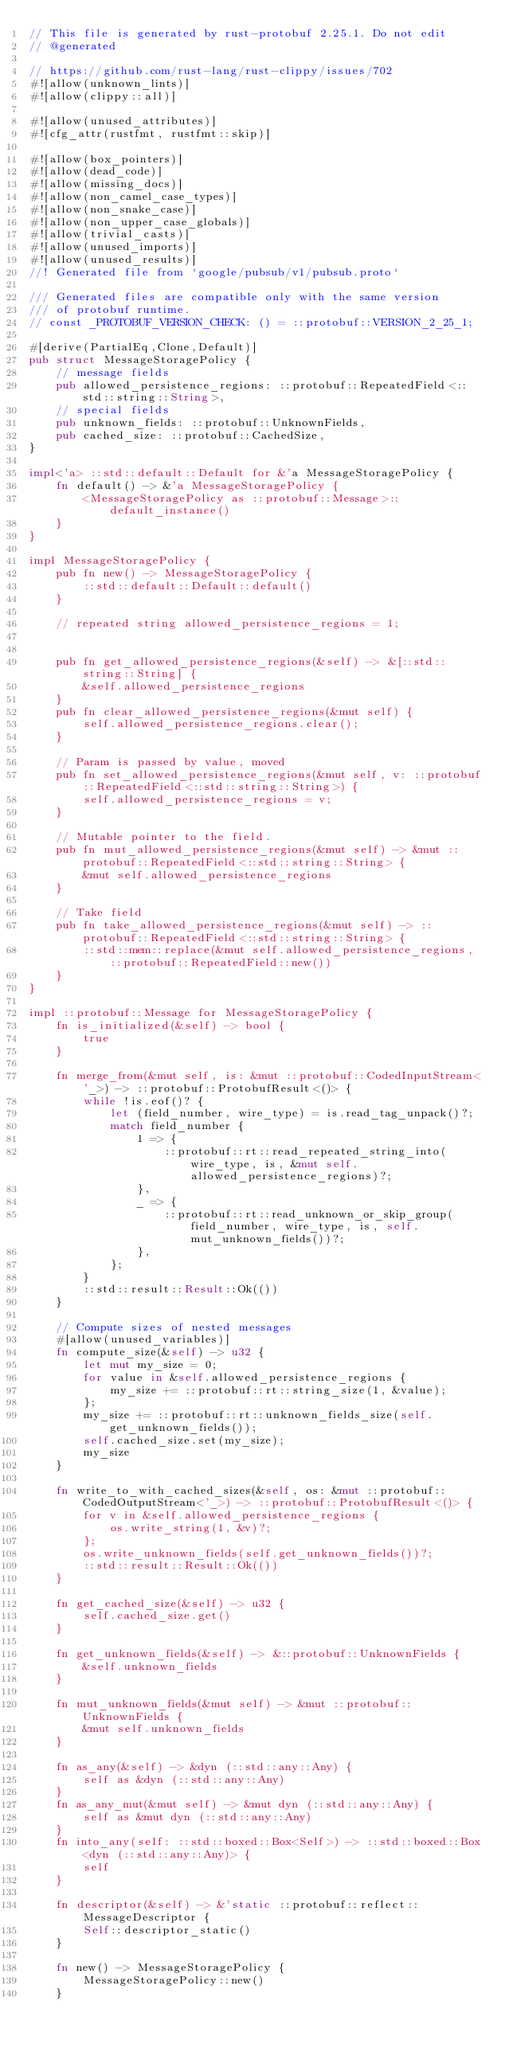Convert code to text. <code><loc_0><loc_0><loc_500><loc_500><_Rust_>// This file is generated by rust-protobuf 2.25.1. Do not edit
// @generated

// https://github.com/rust-lang/rust-clippy/issues/702
#![allow(unknown_lints)]
#![allow(clippy::all)]

#![allow(unused_attributes)]
#![cfg_attr(rustfmt, rustfmt::skip)]

#![allow(box_pointers)]
#![allow(dead_code)]
#![allow(missing_docs)]
#![allow(non_camel_case_types)]
#![allow(non_snake_case)]
#![allow(non_upper_case_globals)]
#![allow(trivial_casts)]
#![allow(unused_imports)]
#![allow(unused_results)]
//! Generated file from `google/pubsub/v1/pubsub.proto`

/// Generated files are compatible only with the same version
/// of protobuf runtime.
// const _PROTOBUF_VERSION_CHECK: () = ::protobuf::VERSION_2_25_1;

#[derive(PartialEq,Clone,Default)]
pub struct MessageStoragePolicy {
    // message fields
    pub allowed_persistence_regions: ::protobuf::RepeatedField<::std::string::String>,
    // special fields
    pub unknown_fields: ::protobuf::UnknownFields,
    pub cached_size: ::protobuf::CachedSize,
}

impl<'a> ::std::default::Default for &'a MessageStoragePolicy {
    fn default() -> &'a MessageStoragePolicy {
        <MessageStoragePolicy as ::protobuf::Message>::default_instance()
    }
}

impl MessageStoragePolicy {
    pub fn new() -> MessageStoragePolicy {
        ::std::default::Default::default()
    }

    // repeated string allowed_persistence_regions = 1;


    pub fn get_allowed_persistence_regions(&self) -> &[::std::string::String] {
        &self.allowed_persistence_regions
    }
    pub fn clear_allowed_persistence_regions(&mut self) {
        self.allowed_persistence_regions.clear();
    }

    // Param is passed by value, moved
    pub fn set_allowed_persistence_regions(&mut self, v: ::protobuf::RepeatedField<::std::string::String>) {
        self.allowed_persistence_regions = v;
    }

    // Mutable pointer to the field.
    pub fn mut_allowed_persistence_regions(&mut self) -> &mut ::protobuf::RepeatedField<::std::string::String> {
        &mut self.allowed_persistence_regions
    }

    // Take field
    pub fn take_allowed_persistence_regions(&mut self) -> ::protobuf::RepeatedField<::std::string::String> {
        ::std::mem::replace(&mut self.allowed_persistence_regions, ::protobuf::RepeatedField::new())
    }
}

impl ::protobuf::Message for MessageStoragePolicy {
    fn is_initialized(&self) -> bool {
        true
    }

    fn merge_from(&mut self, is: &mut ::protobuf::CodedInputStream<'_>) -> ::protobuf::ProtobufResult<()> {
        while !is.eof()? {
            let (field_number, wire_type) = is.read_tag_unpack()?;
            match field_number {
                1 => {
                    ::protobuf::rt::read_repeated_string_into(wire_type, is, &mut self.allowed_persistence_regions)?;
                },
                _ => {
                    ::protobuf::rt::read_unknown_or_skip_group(field_number, wire_type, is, self.mut_unknown_fields())?;
                },
            };
        }
        ::std::result::Result::Ok(())
    }

    // Compute sizes of nested messages
    #[allow(unused_variables)]
    fn compute_size(&self) -> u32 {
        let mut my_size = 0;
        for value in &self.allowed_persistence_regions {
            my_size += ::protobuf::rt::string_size(1, &value);
        };
        my_size += ::protobuf::rt::unknown_fields_size(self.get_unknown_fields());
        self.cached_size.set(my_size);
        my_size
    }

    fn write_to_with_cached_sizes(&self, os: &mut ::protobuf::CodedOutputStream<'_>) -> ::protobuf::ProtobufResult<()> {
        for v in &self.allowed_persistence_regions {
            os.write_string(1, &v)?;
        };
        os.write_unknown_fields(self.get_unknown_fields())?;
        ::std::result::Result::Ok(())
    }

    fn get_cached_size(&self) -> u32 {
        self.cached_size.get()
    }

    fn get_unknown_fields(&self) -> &::protobuf::UnknownFields {
        &self.unknown_fields
    }

    fn mut_unknown_fields(&mut self) -> &mut ::protobuf::UnknownFields {
        &mut self.unknown_fields
    }

    fn as_any(&self) -> &dyn (::std::any::Any) {
        self as &dyn (::std::any::Any)
    }
    fn as_any_mut(&mut self) -> &mut dyn (::std::any::Any) {
        self as &mut dyn (::std::any::Any)
    }
    fn into_any(self: ::std::boxed::Box<Self>) -> ::std::boxed::Box<dyn (::std::any::Any)> {
        self
    }

    fn descriptor(&self) -> &'static ::protobuf::reflect::MessageDescriptor {
        Self::descriptor_static()
    }

    fn new() -> MessageStoragePolicy {
        MessageStoragePolicy::new()
    }
</code> 